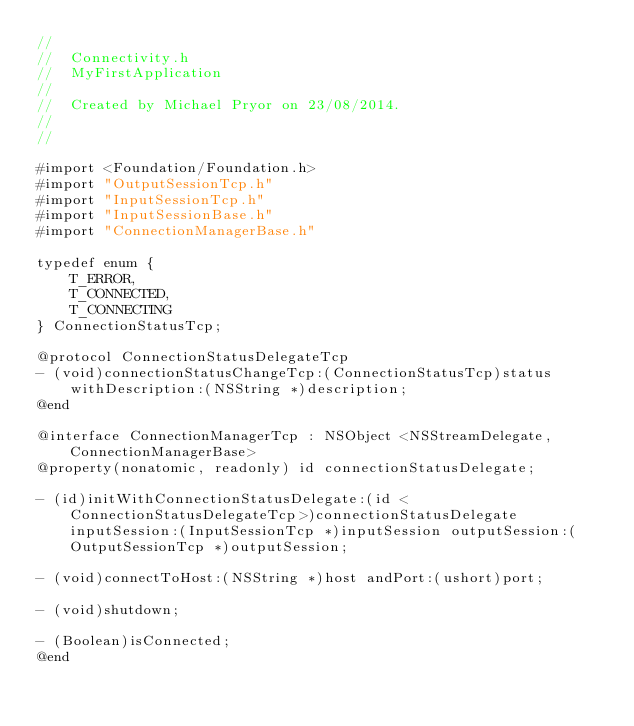<code> <loc_0><loc_0><loc_500><loc_500><_C_>//
//  Connectivity.h
//  MyFirstApplication
//
//  Created by Michael Pryor on 23/08/2014.
//
//

#import <Foundation/Foundation.h>
#import "OutputSessionTcp.h"
#import "InputSessionTcp.h"
#import "InputSessionBase.h"
#import "ConnectionManagerBase.h"

typedef enum {
    T_ERROR,
    T_CONNECTED,
    T_CONNECTING
} ConnectionStatusTcp;

@protocol ConnectionStatusDelegateTcp
- (void)connectionStatusChangeTcp:(ConnectionStatusTcp)status withDescription:(NSString *)description;
@end

@interface ConnectionManagerTcp : NSObject <NSStreamDelegate, ConnectionManagerBase>
@property(nonatomic, readonly) id connectionStatusDelegate;

- (id)initWithConnectionStatusDelegate:(id <ConnectionStatusDelegateTcp>)connectionStatusDelegate inputSession:(InputSessionTcp *)inputSession outputSession:(OutputSessionTcp *)outputSession;

- (void)connectToHost:(NSString *)host andPort:(ushort)port;

- (void)shutdown;

- (Boolean)isConnected;
@end



</code> 